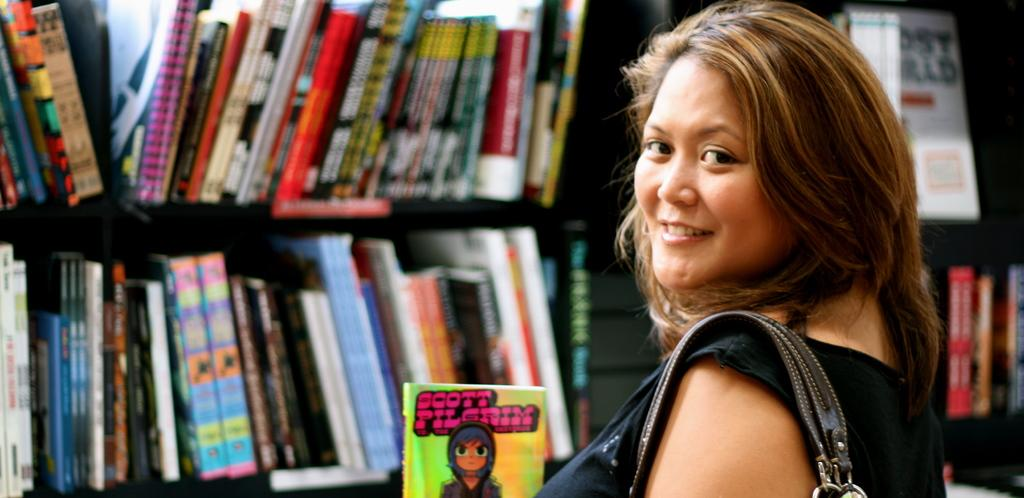<image>
Give a short and clear explanation of the subsequent image. A woman at a book store holding the book Scott Pilgram 